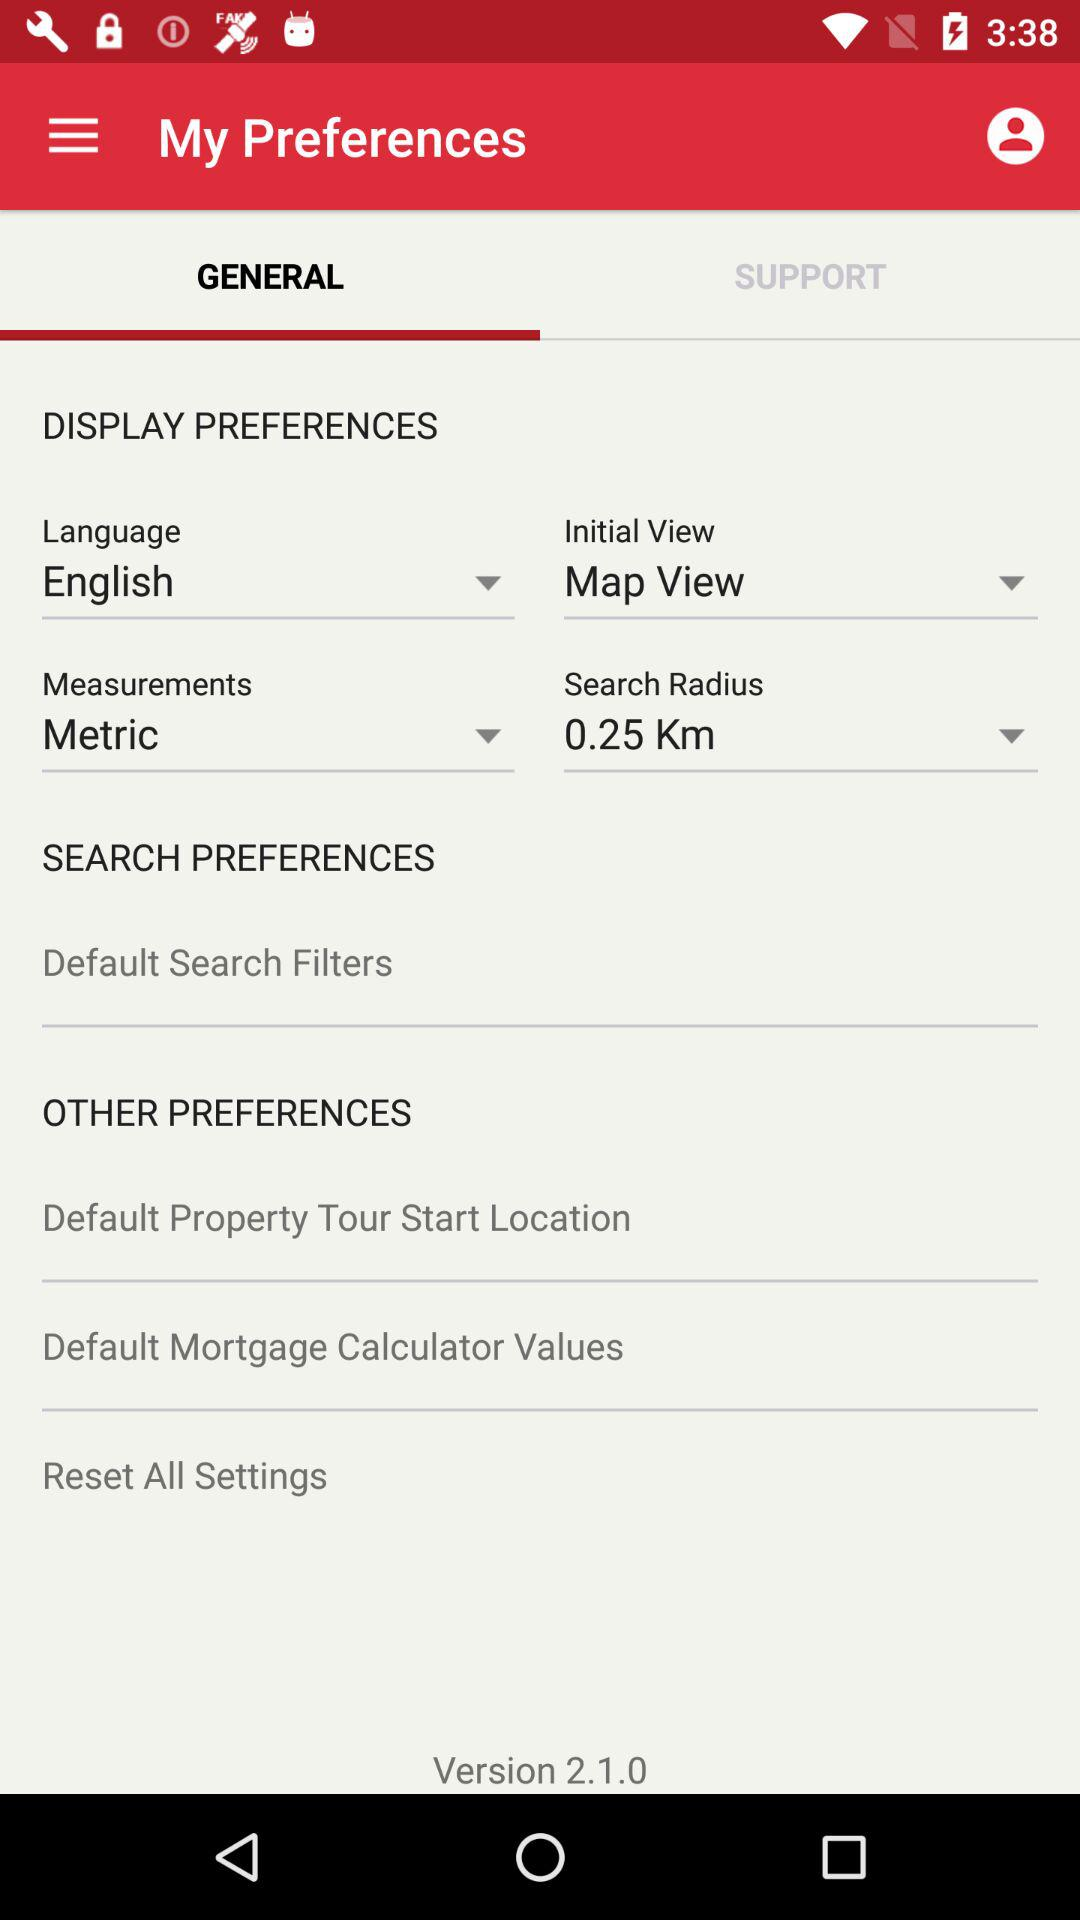How much is the search radius? The search radius is 0.25 km. 